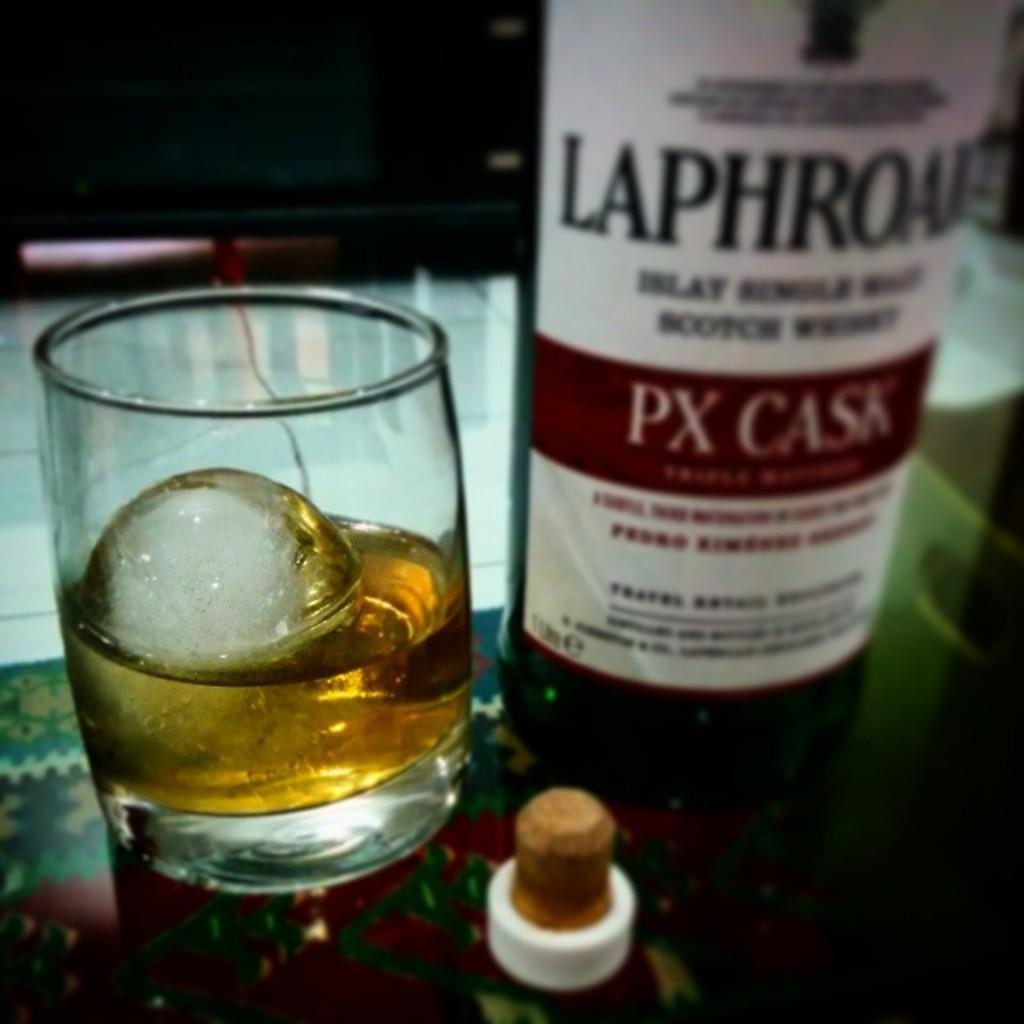<image>
Create a compact narrative representing the image presented. a glass and bottle of PX Cask on a table with a cork 